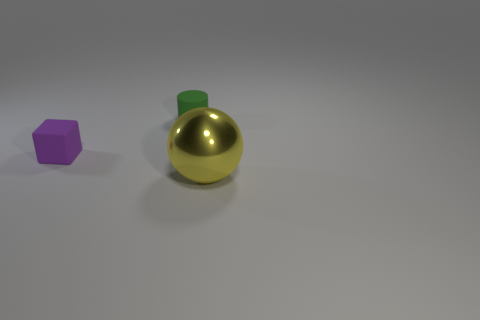Subtract all blue spheres. Subtract all brown cubes. How many spheres are left? 1 Add 1 brown matte balls. How many objects exist? 4 Subtract all spheres. How many objects are left? 2 Add 2 purple cubes. How many purple cubes exist? 3 Subtract 0 yellow blocks. How many objects are left? 3 Subtract all cubes. Subtract all yellow spheres. How many objects are left? 1 Add 2 tiny cylinders. How many tiny cylinders are left? 3 